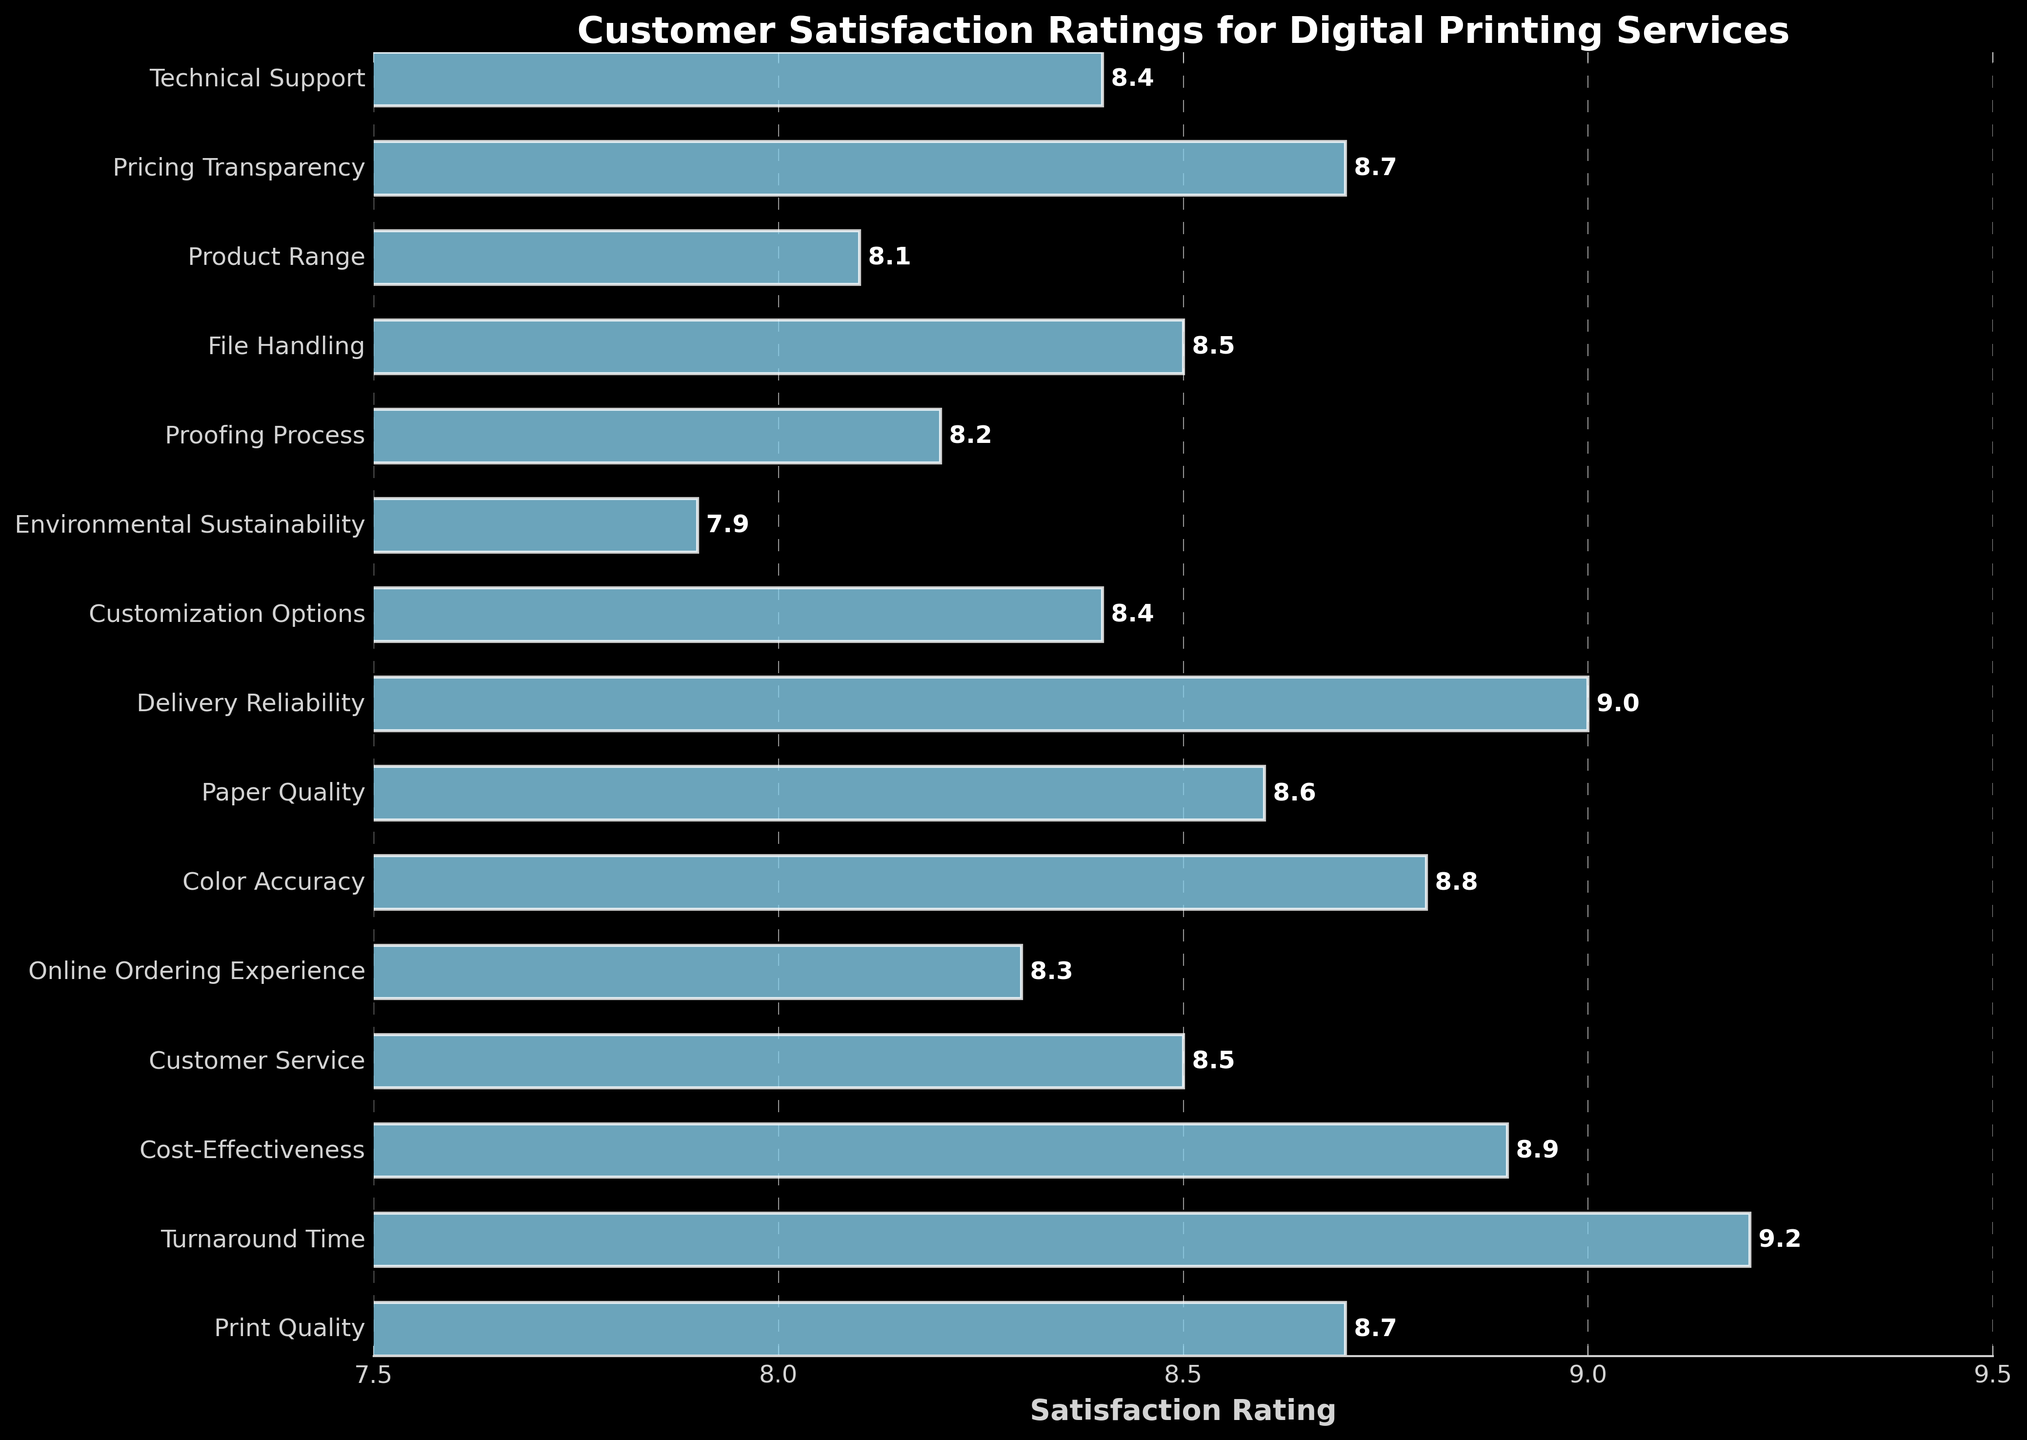Which factor has the highest customer satisfaction rating? The bar representing 'Turnaround Time' is the longest on the chart, indicating it has the highest rating.
Answer: Turnaround Time Which factor has the lowest customer satisfaction rating? The bar representing 'Environmental Sustainability' is the shortest on the chart, indicating it has the lowest rating.
Answer: Environmental Sustainability How does the satisfaction rating for 'Print Quality' compare to 'Customer Service'? The bar for 'Print Quality' is longer than the bar for 'Customer Service', meaning 'Print Quality' has a higher satisfaction rating.
Answer: Print Quality is higher Is the satisfaction rating for 'Pricing Transparency' equal to 'Print Quality'? Yes, the lengths of the bars for 'Pricing Transparency' and 'Print Quality' are the same, indicating equal satisfaction ratings.
Answer: Yes What is the average satisfaction rating for 'Turnaround Time', 'Cost-Effectiveness', and 'Delivery Reliability'? Add the satisfaction ratings: 9.2 (Turnaround Time) + 8.9 (Cost-Effectiveness) + 9.0 (Delivery Reliability) = 27.1. Divide by the number of factors: 27.1 / 3 = 9.03.
Answer: 9.03 What is the difference in satisfaction rating between 'Color Accuracy' and 'Environmental Sustainability'? Subtract the satisfaction rating of Environmental Sustainability (7.9) from Color Accuracy (8.8): 8.8 - 7.9 = 0.9.
Answer: 0.9 Which factors have a satisfaction rating above 9? The bars representing 'Turnaround Time' (9.2) and 'Delivery Reliability' (9.0) are both at or above 9.
Answer: Turnaround Time, Delivery Reliability How many factors have satisfaction ratings between 8.0 and 8.5 inclusive? The factors with ratings of 8.0 to 8.5 are: 'Customer Service' (8.5), 'Online Ordering Experience' (8.3), 'Paper Quality' (8.6), 'Customization Options' (8.4), 'Proofing Process' (8.2), 'File Handling' (8.5), 'Product Range' (8.1), 'Technical Support' (8.4). Total is 7.
Answer: 7 Are there any factors rated below 8.0? The bar for 'Environmental Sustainability' is the only one shorter than 8.0, indicating it's below 8.0.
Answer: Yes 